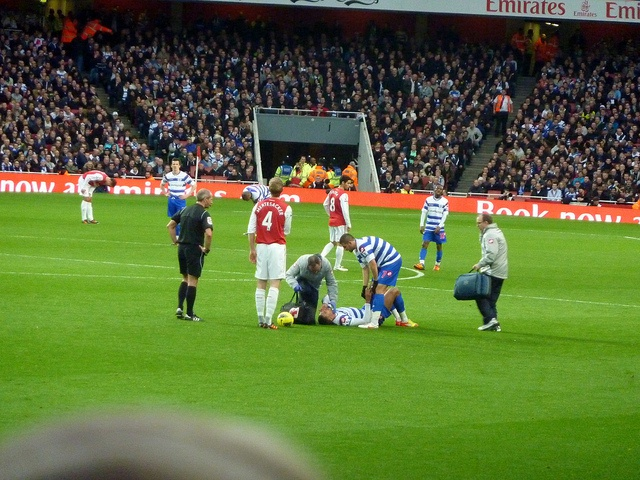Describe the objects in this image and their specific colors. I can see people in black, gray, maroon, and darkgray tones, people in black, ivory, brown, olive, and darkgray tones, people in black, olive, and gray tones, people in black, blue, white, and olive tones, and people in black, darkgray, and beige tones in this image. 